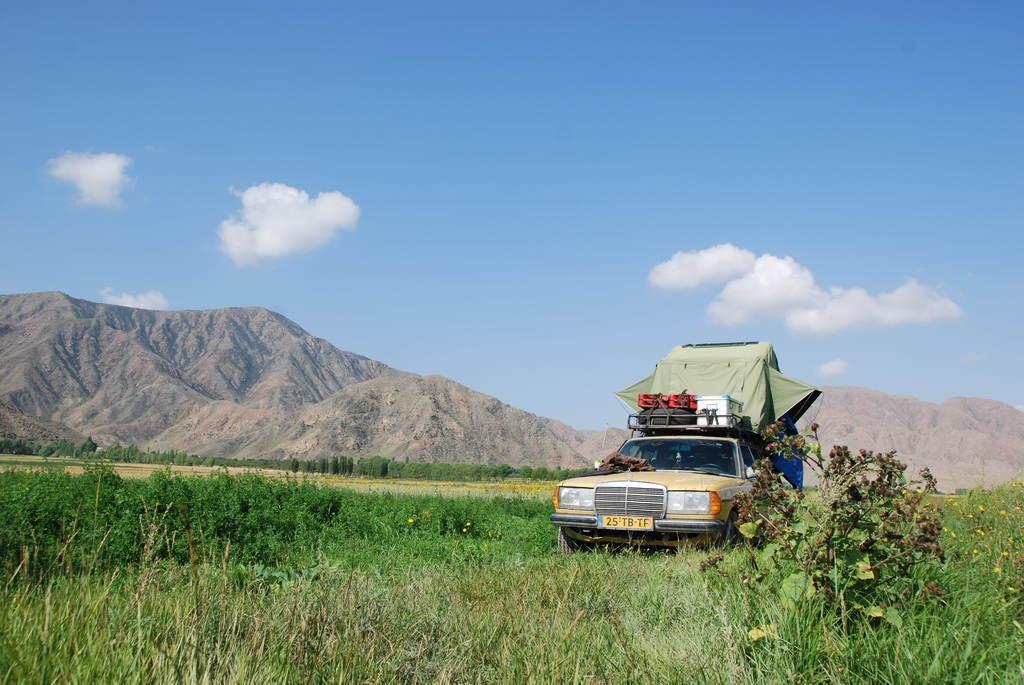Please provide a concise description of this image. In this picture there is a vehicle on the right side of the image on the grassland, it seems to be there is a tent on a vehicle and there is greenery at the bottom side of the image and there is sky at the top side of the image. 